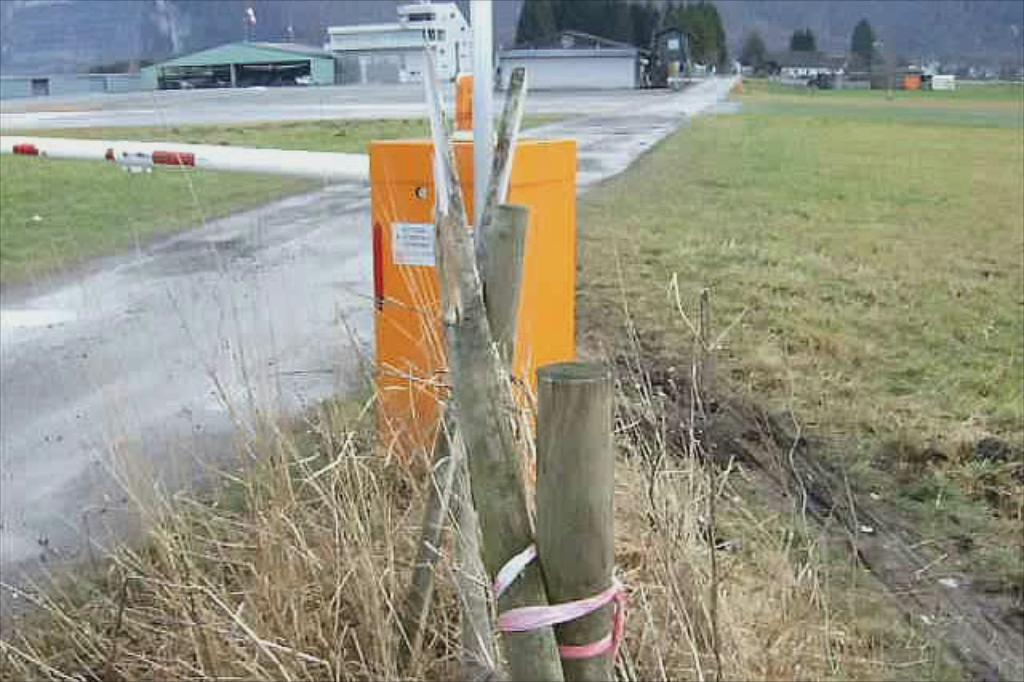What type of objects are made of wood in the image? The image contains wooden sticks. What is the color of the grass on the ground? The grass on the ground is green. What can be seen on the left side of the image? There is a road on the left side of the image. What is visible in the background of the image? There are buildings and trees in the background of the image. What type of bread can be seen in the image? There is no bread present in the image. Can you hear a voice requesting something in the image? The image is a still picture and does not contain any sound or voice. 